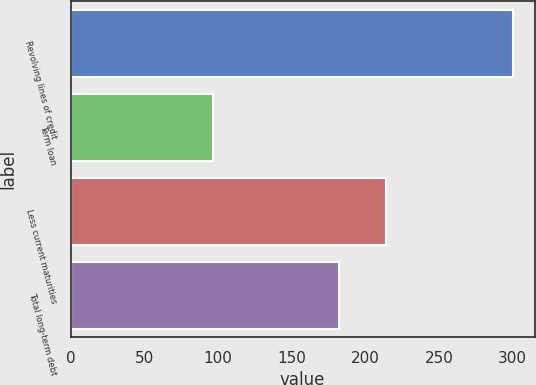Convert chart. <chart><loc_0><loc_0><loc_500><loc_500><bar_chart><fcel>Revolving lines of credit<fcel>Term loan<fcel>Less current maturities<fcel>Total long-term debt<nl><fcel>299.9<fcel>96.5<fcel>214<fcel>182.4<nl></chart> 